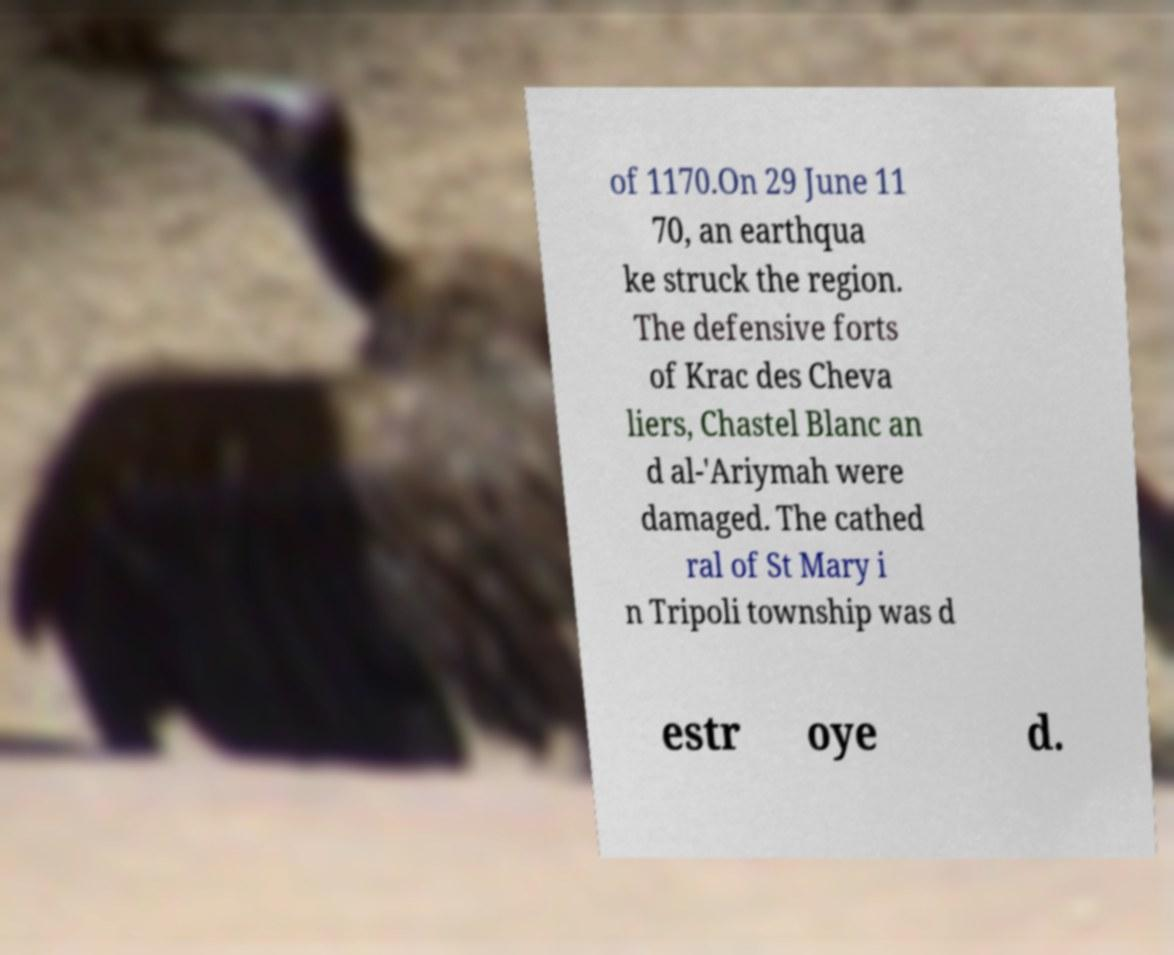Could you extract and type out the text from this image? of 1170.On 29 June 11 70, an earthqua ke struck the region. The defensive forts of Krac des Cheva liers, Chastel Blanc an d al-'Ariymah were damaged. The cathed ral of St Mary i n Tripoli township was d estr oye d. 